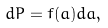Convert formula to latex. <formula><loc_0><loc_0><loc_500><loc_500>d P = f ( a ) d a ,</formula> 